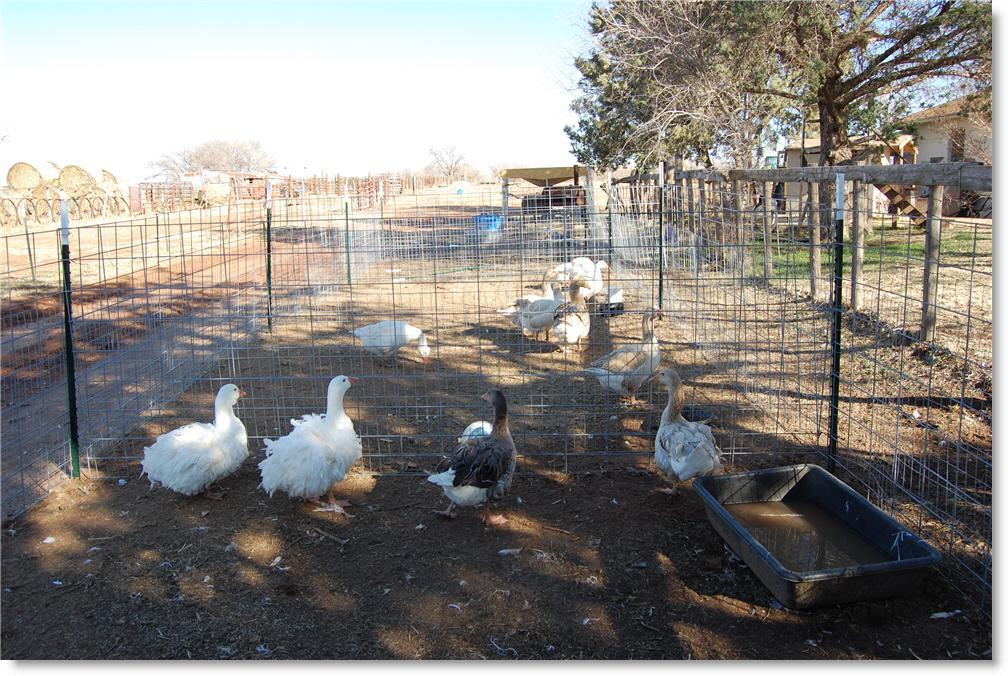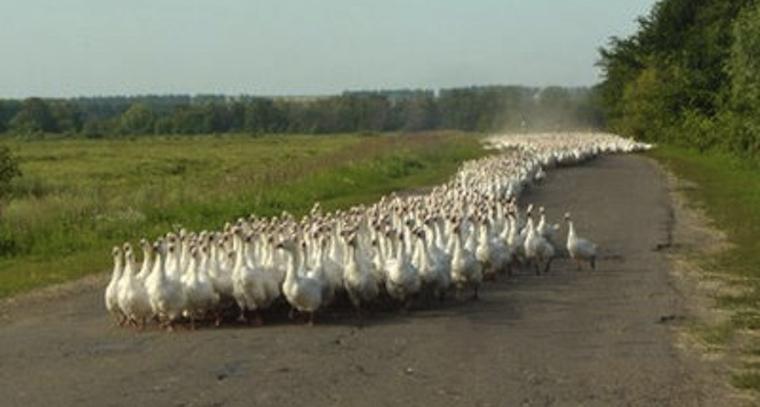The first image is the image on the left, the second image is the image on the right. For the images displayed, is the sentence "Neither of the images of geese contains a human standing on the ground." factually correct? Answer yes or no. Yes. 